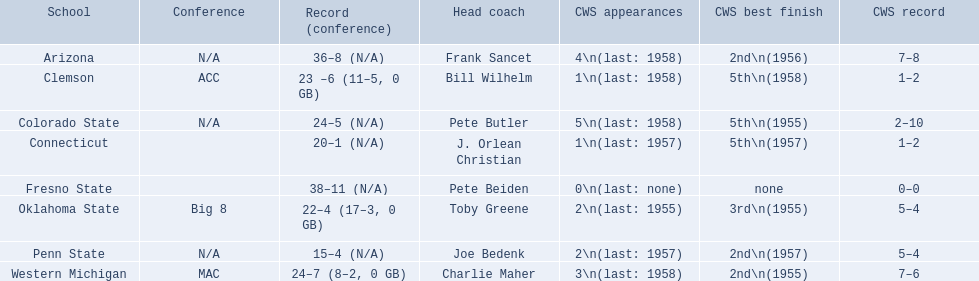In the 1959 ncaa tournament, what were the respective scores for all participating schools? 36–8 (N/A), 23 –6 (11–5, 0 GB), 24–5 (N/A), 20–1 (N/A), 38–11 (N/A), 22–4 (17–3, 0 GB), 15–4 (N/A), 24–7 (8–2, 0 GB). Which score had less than 16 wins? 15–4 (N/A). What team had this score? Penn State. 